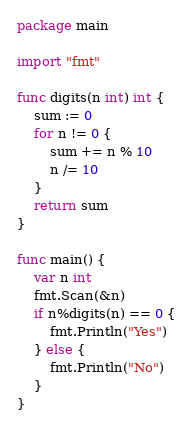Convert code to text. <code><loc_0><loc_0><loc_500><loc_500><_Go_>package main

import "fmt"

func digits(n int) int {
	sum := 0
	for n != 0 {
		sum += n % 10
		n /= 10
	}
	return sum
}

func main() {
	var n int
	fmt.Scan(&n)
	if n%digits(n) == 0 {
		fmt.Println("Yes")
	} else {
		fmt.Println("No")
	}
}
</code> 